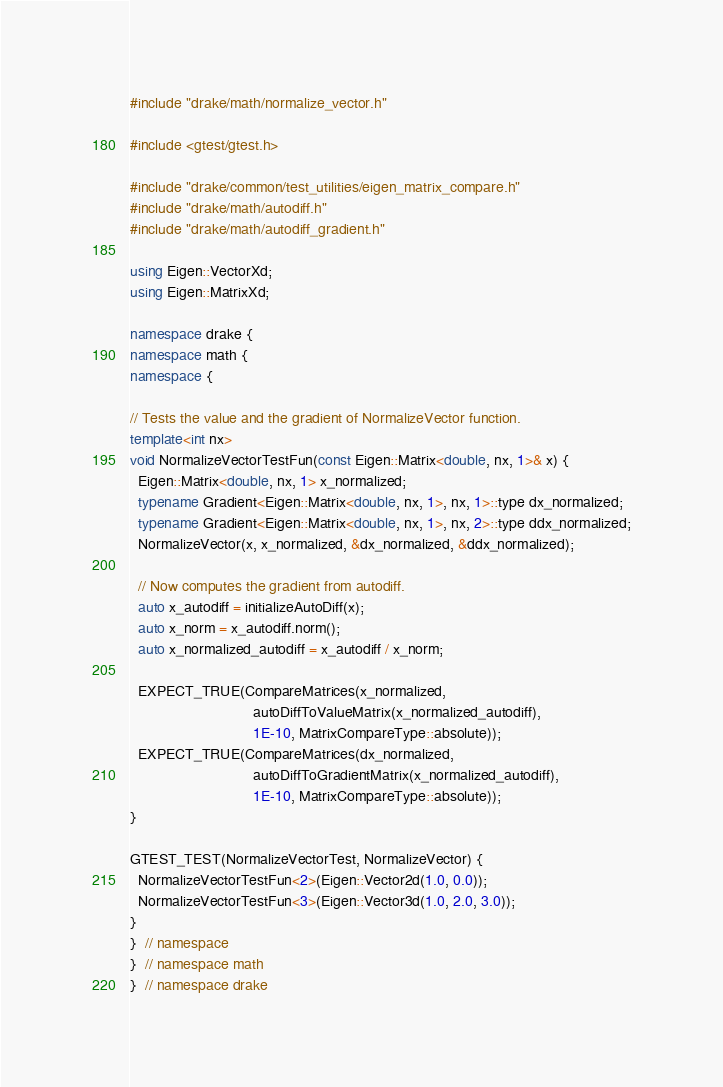Convert code to text. <code><loc_0><loc_0><loc_500><loc_500><_C++_>#include "drake/math/normalize_vector.h"

#include <gtest/gtest.h>

#include "drake/common/test_utilities/eigen_matrix_compare.h"
#include "drake/math/autodiff.h"
#include "drake/math/autodiff_gradient.h"

using Eigen::VectorXd;
using Eigen::MatrixXd;

namespace drake {
namespace math {
namespace {

// Tests the value and the gradient of NormalizeVector function.
template<int nx>
void NormalizeVectorTestFun(const Eigen::Matrix<double, nx, 1>& x) {
  Eigen::Matrix<double, nx, 1> x_normalized;
  typename Gradient<Eigen::Matrix<double, nx, 1>, nx, 1>::type dx_normalized;
  typename Gradient<Eigen::Matrix<double, nx, 1>, nx, 2>::type ddx_normalized;
  NormalizeVector(x, x_normalized, &dx_normalized, &ddx_normalized);

  // Now computes the gradient from autodiff.
  auto x_autodiff = initializeAutoDiff(x);
  auto x_norm = x_autodiff.norm();
  auto x_normalized_autodiff = x_autodiff / x_norm;

  EXPECT_TRUE(CompareMatrices(x_normalized,
                              autoDiffToValueMatrix(x_normalized_autodiff),
                              1E-10, MatrixCompareType::absolute));
  EXPECT_TRUE(CompareMatrices(dx_normalized,
                              autoDiffToGradientMatrix(x_normalized_autodiff),
                              1E-10, MatrixCompareType::absolute));
}

GTEST_TEST(NormalizeVectorTest, NormalizeVector) {
  NormalizeVectorTestFun<2>(Eigen::Vector2d(1.0, 0.0));
  NormalizeVectorTestFun<3>(Eigen::Vector3d(1.0, 2.0, 3.0));
}
}  // namespace
}  // namespace math
}  // namespace drake
</code> 